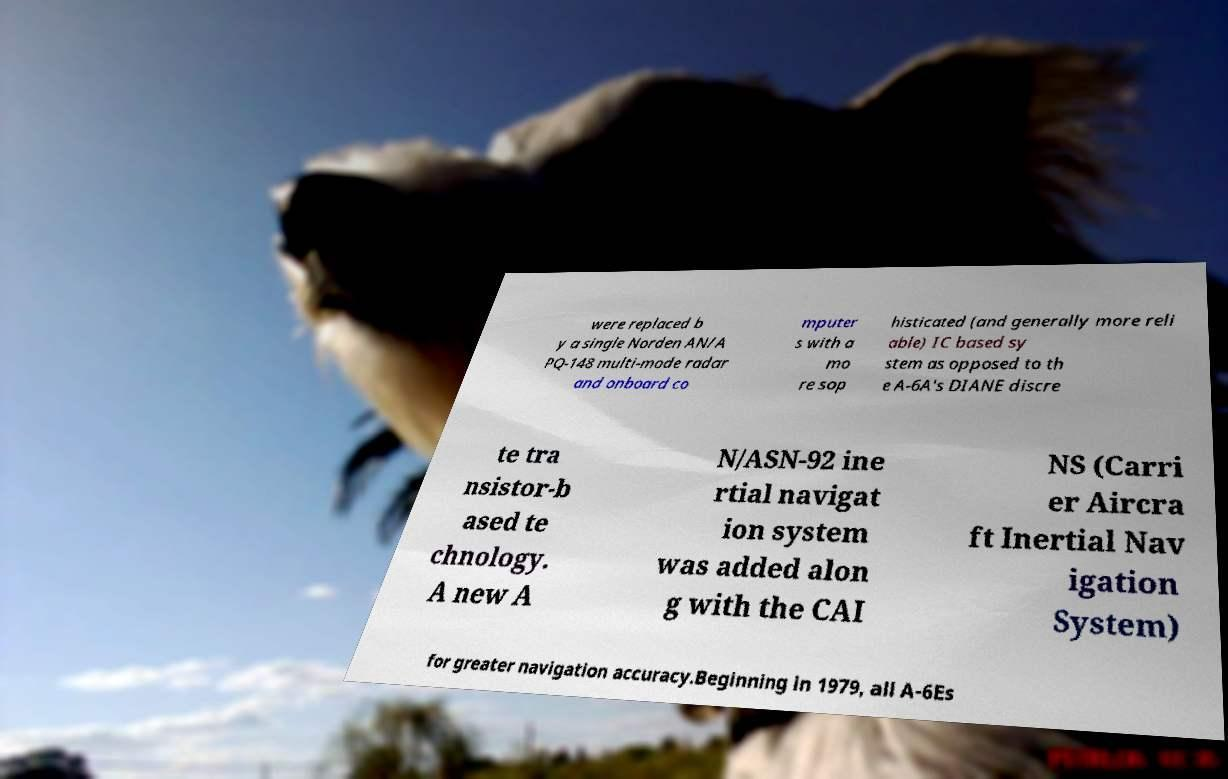There's text embedded in this image that I need extracted. Can you transcribe it verbatim? were replaced b y a single Norden AN/A PQ-148 multi-mode radar and onboard co mputer s with a mo re sop histicated (and generally more reli able) IC based sy stem as opposed to th e A-6A's DIANE discre te tra nsistor-b ased te chnology. A new A N/ASN-92 ine rtial navigat ion system was added alon g with the CAI NS (Carri er Aircra ft Inertial Nav igation System) for greater navigation accuracy.Beginning in 1979, all A-6Es 